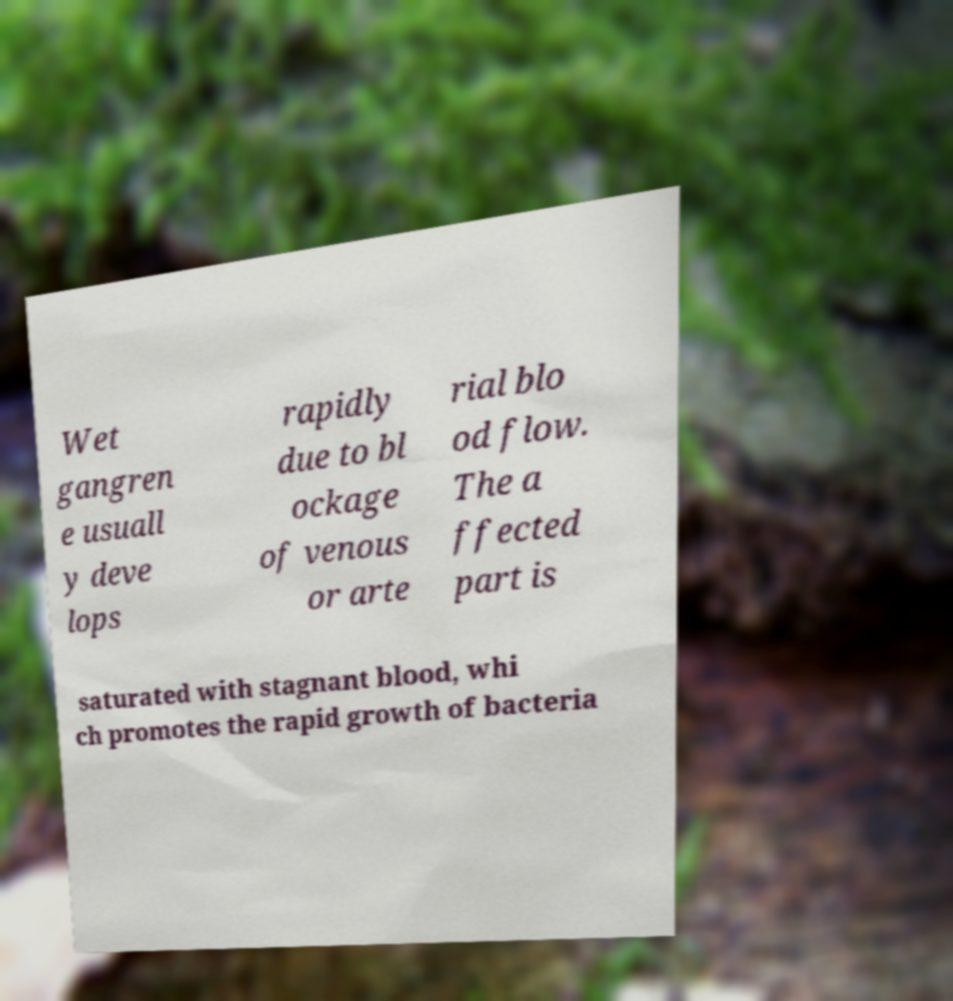Please identify and transcribe the text found in this image. Wet gangren e usuall y deve lops rapidly due to bl ockage of venous or arte rial blo od flow. The a ffected part is saturated with stagnant blood, whi ch promotes the rapid growth of bacteria 